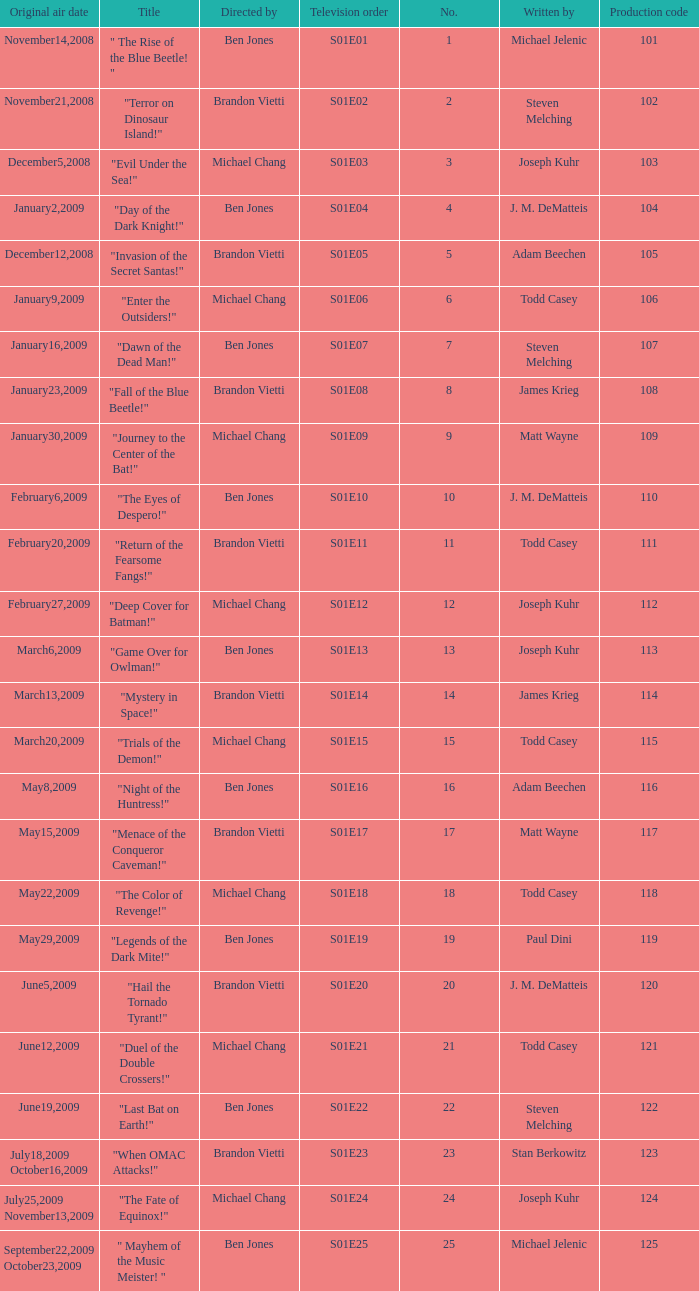What is the the television order of "deep cover for batman!" S01E12. 